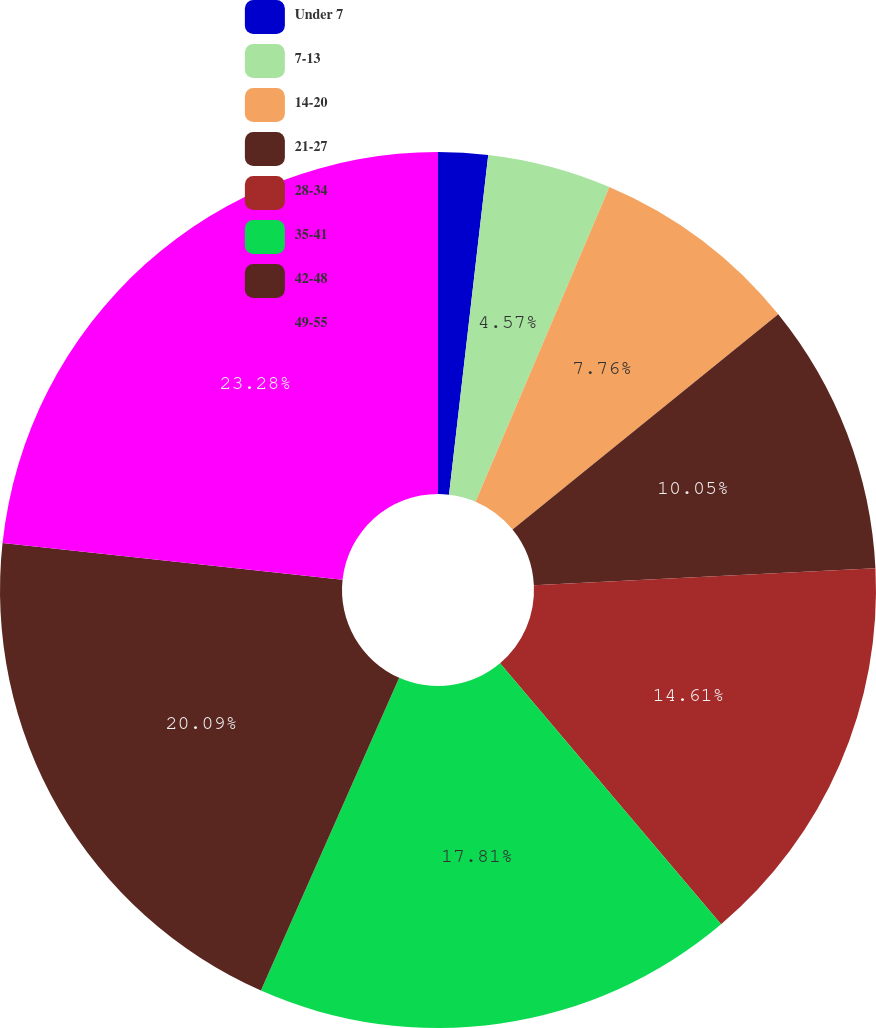Convert chart. <chart><loc_0><loc_0><loc_500><loc_500><pie_chart><fcel>Under 7<fcel>7-13<fcel>14-20<fcel>21-27<fcel>28-34<fcel>35-41<fcel>42-48<fcel>49-55<nl><fcel>1.83%<fcel>4.57%<fcel>7.76%<fcel>10.05%<fcel>14.61%<fcel>17.81%<fcel>20.09%<fcel>23.29%<nl></chart> 